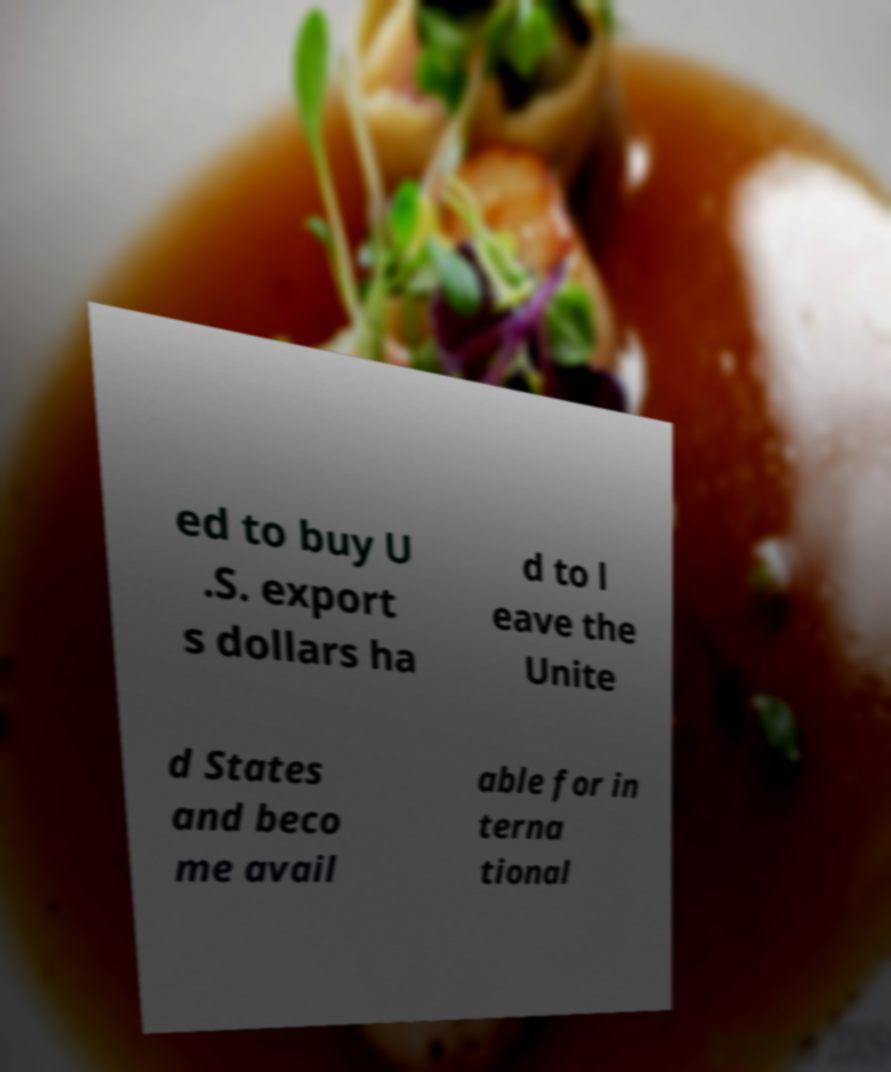I need the written content from this picture converted into text. Can you do that? ed to buy U .S. export s dollars ha d to l eave the Unite d States and beco me avail able for in terna tional 